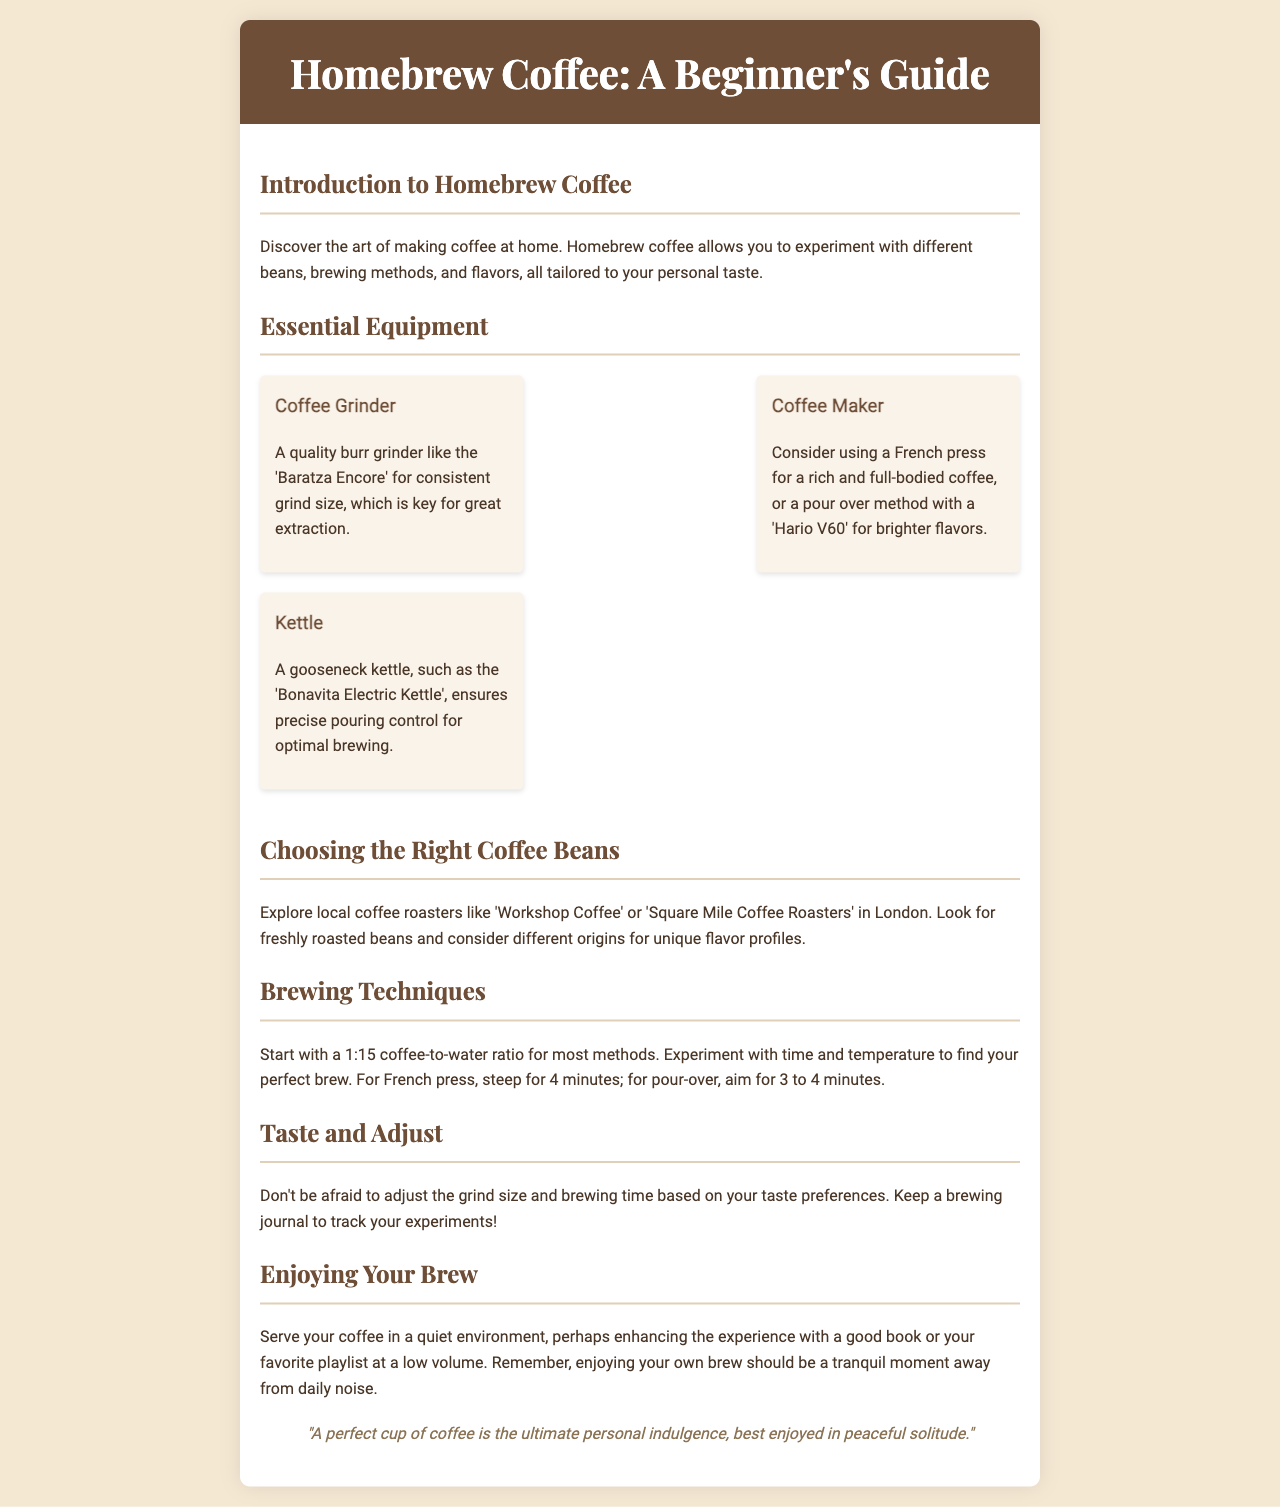what is the title of the brochure? The title is prominently displayed at the top of the document in a large font.
Answer: Homebrew Coffee: A Beginner's Guide what is the recommended coffee grinder mentioned? The document lists specific equipment for home brewing, including a grinder.
Answer: Baratza Encore what coffee making method is suggested for a full-bodied coffee? The document describes different coffee makers and their results.
Answer: French press what is the suggested coffee-to-water ratio? The brewing techniques section provides standard measurements for a good brew.
Answer: 1:15 how long should you steep coffee using a French press? This information is given in the brewing techniques section.
Answer: 4 minutes what type of kettle is recommended for optimal brewing? The unique equipment section highlights specific tools for best results.
Answer: Bonavita Electric Kettle which local coffee roasters are mentioned? The document provides suggestions for local sources of coffee beans in London.
Answer: Workshop Coffee, Square Mile Coffee Roasters what is the focus for enjoying your brew? The guide mentions how to create a suitable ambiance for savoring coffee.
Answer: Quiet environment what does the quote in the brochure convey? The quote reflects on the personal experience of enjoying coffee.
Answer: A perfect cup of coffee is the ultimate personal indulgence, best enjoyed in peaceful solitude 